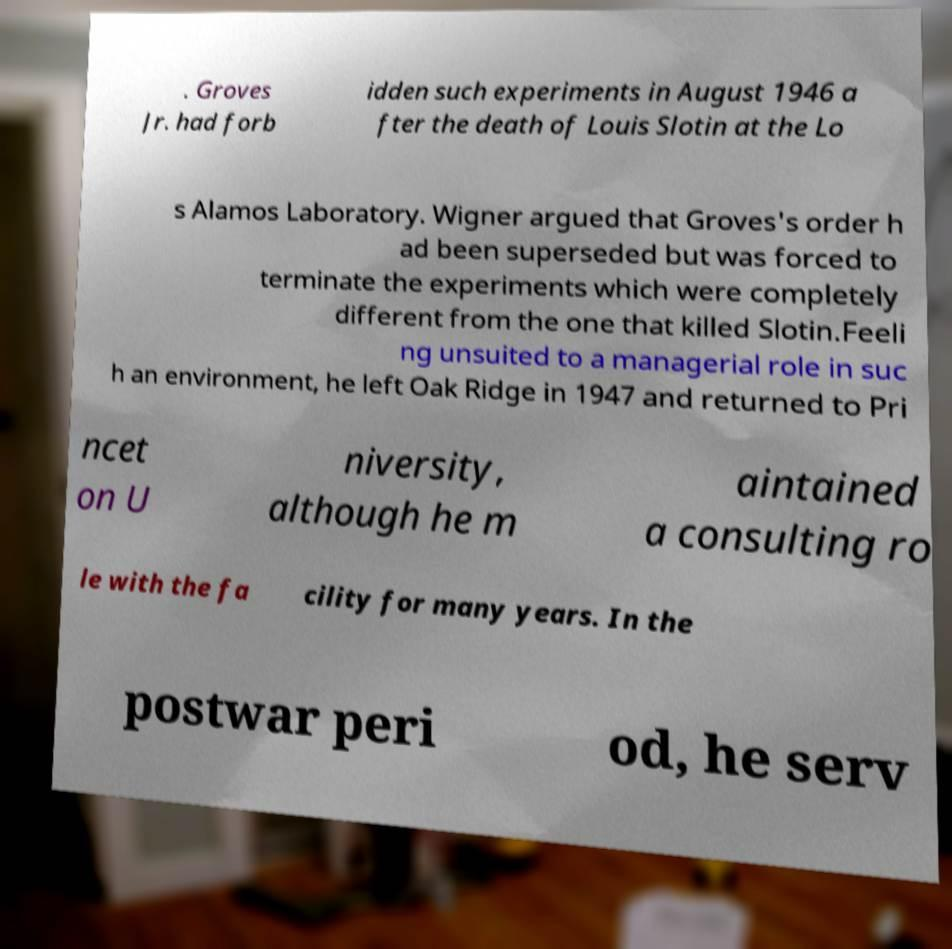Can you accurately transcribe the text from the provided image for me? . Groves Jr. had forb idden such experiments in August 1946 a fter the death of Louis Slotin at the Lo s Alamos Laboratory. Wigner argued that Groves's order h ad been superseded but was forced to terminate the experiments which were completely different from the one that killed Slotin.Feeli ng unsuited to a managerial role in suc h an environment, he left Oak Ridge in 1947 and returned to Pri ncet on U niversity, although he m aintained a consulting ro le with the fa cility for many years. In the postwar peri od, he serv 